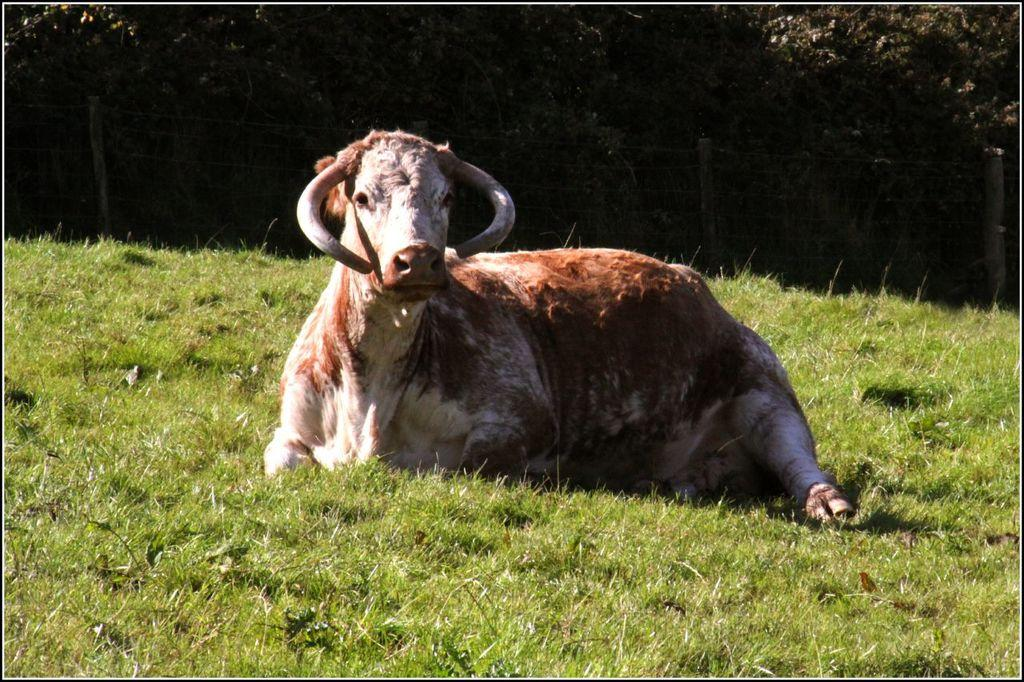What is the main subject in the center of the image? There is an animal in the center of the image. What type of natural environment is visible in the background? There is grass visible in the background of the image. What type of barrier is present at the top of the image? There is fencing at the top of the image. What type of vegetation is present at the top of the image? Trees are present at the top of the image. What type of spark can be seen coming from the animal's vein in the image? There is no spark or vein visible in the image; it features an animal, grass, fencing, and trees. 